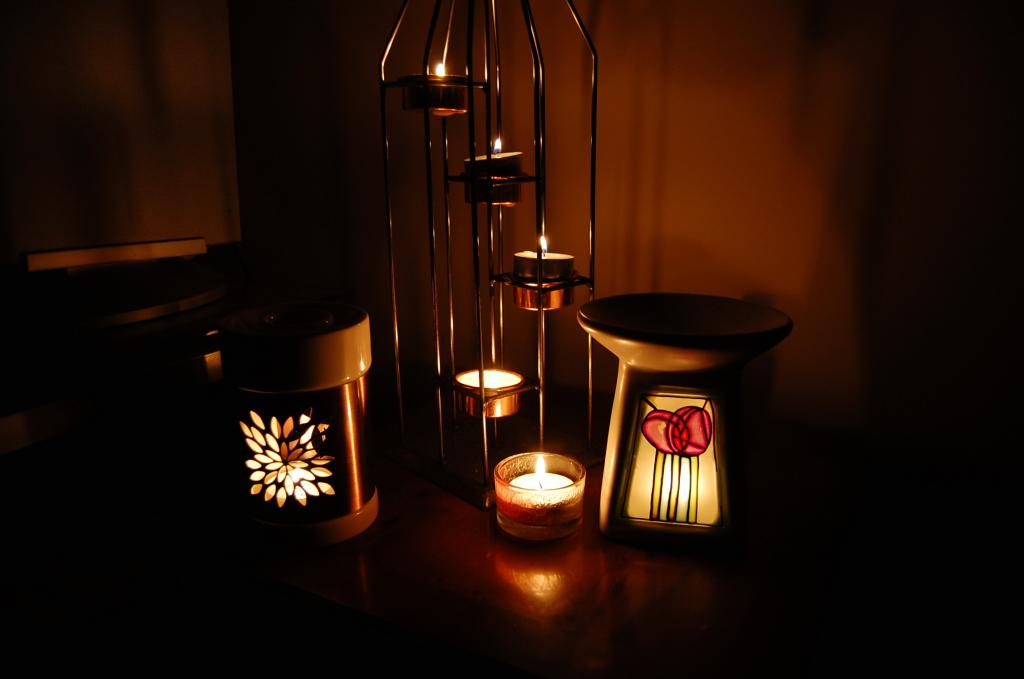What is located in the stand in the image? There are days in the stand in the image. What can be seen on the table in the image? There are objects on the table in the image. How would you describe the color scheme of the background in the image? The background of the image is in brown and black colors. Where is the drawer located in the image? There is no drawer present in the image. How many hydrants can be seen in the image? There are no hydrants present in the image. 